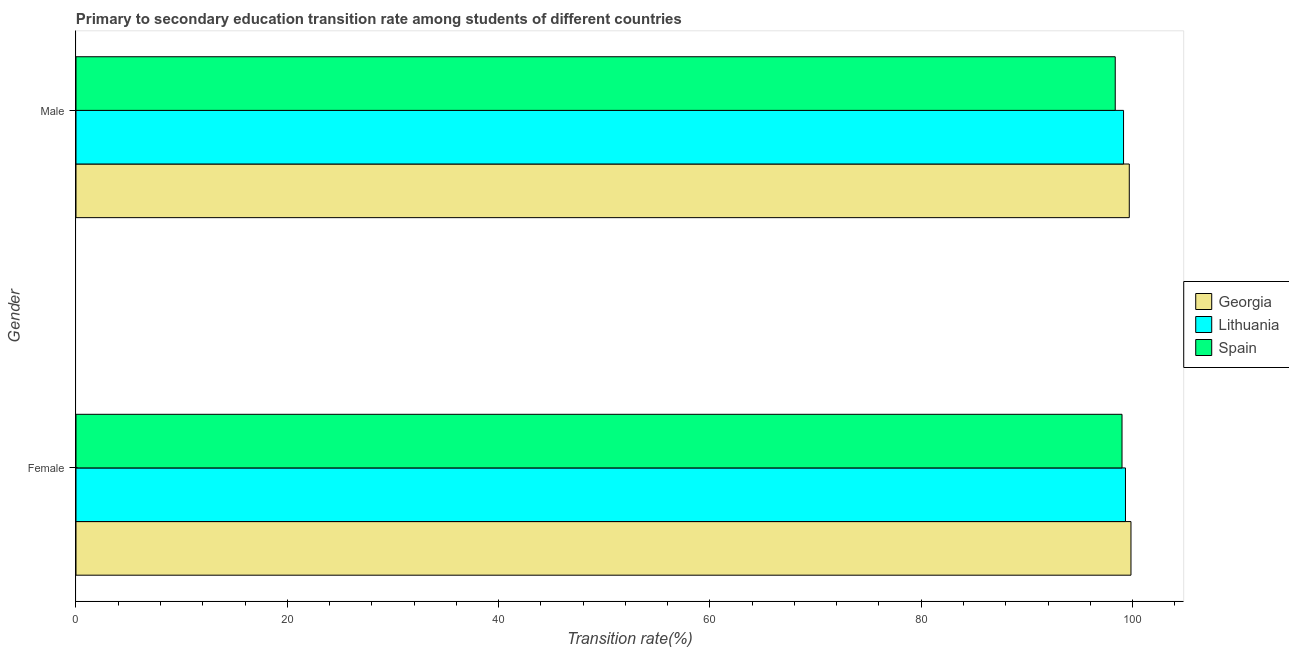How many different coloured bars are there?
Your answer should be compact. 3. How many groups of bars are there?
Ensure brevity in your answer.  2. Are the number of bars per tick equal to the number of legend labels?
Provide a succinct answer. Yes. How many bars are there on the 2nd tick from the bottom?
Your answer should be very brief. 3. What is the transition rate among male students in Spain?
Provide a succinct answer. 98.36. Across all countries, what is the maximum transition rate among male students?
Keep it short and to the point. 99.69. Across all countries, what is the minimum transition rate among male students?
Your answer should be very brief. 98.36. In which country was the transition rate among male students maximum?
Keep it short and to the point. Georgia. What is the total transition rate among male students in the graph?
Give a very brief answer. 297.21. What is the difference between the transition rate among male students in Lithuania and that in Spain?
Give a very brief answer. 0.79. What is the difference between the transition rate among female students in Georgia and the transition rate among male students in Lithuania?
Ensure brevity in your answer.  0.7. What is the average transition rate among male students per country?
Provide a succinct answer. 99.07. What is the difference between the transition rate among female students and transition rate among male students in Lithuania?
Provide a succinct answer. 0.18. In how many countries, is the transition rate among female students greater than 56 %?
Ensure brevity in your answer.  3. What is the ratio of the transition rate among female students in Lithuania to that in Georgia?
Ensure brevity in your answer.  0.99. Is the transition rate among male students in Spain less than that in Georgia?
Give a very brief answer. Yes. In how many countries, is the transition rate among female students greater than the average transition rate among female students taken over all countries?
Ensure brevity in your answer.  1. What does the 2nd bar from the top in Female represents?
Provide a short and direct response. Lithuania. What does the 2nd bar from the bottom in Female represents?
Your response must be concise. Lithuania. How many bars are there?
Give a very brief answer. 6. Are the values on the major ticks of X-axis written in scientific E-notation?
Keep it short and to the point. No. Does the graph contain grids?
Offer a very short reply. No. Where does the legend appear in the graph?
Your response must be concise. Center right. How are the legend labels stacked?
Your answer should be compact. Vertical. What is the title of the graph?
Your answer should be very brief. Primary to secondary education transition rate among students of different countries. Does "Myanmar" appear as one of the legend labels in the graph?
Give a very brief answer. No. What is the label or title of the X-axis?
Your answer should be very brief. Transition rate(%). What is the Transition rate(%) in Georgia in Female?
Give a very brief answer. 99.85. What is the Transition rate(%) in Lithuania in Female?
Offer a terse response. 99.33. What is the Transition rate(%) in Spain in Female?
Offer a very short reply. 99.01. What is the Transition rate(%) of Georgia in Male?
Your response must be concise. 99.69. What is the Transition rate(%) in Lithuania in Male?
Make the answer very short. 99.15. What is the Transition rate(%) in Spain in Male?
Offer a very short reply. 98.36. Across all Gender, what is the maximum Transition rate(%) of Georgia?
Offer a terse response. 99.85. Across all Gender, what is the maximum Transition rate(%) in Lithuania?
Provide a succinct answer. 99.33. Across all Gender, what is the maximum Transition rate(%) in Spain?
Ensure brevity in your answer.  99.01. Across all Gender, what is the minimum Transition rate(%) of Georgia?
Your response must be concise. 99.69. Across all Gender, what is the minimum Transition rate(%) of Lithuania?
Make the answer very short. 99.15. Across all Gender, what is the minimum Transition rate(%) of Spain?
Give a very brief answer. 98.36. What is the total Transition rate(%) of Georgia in the graph?
Ensure brevity in your answer.  199.55. What is the total Transition rate(%) of Lithuania in the graph?
Provide a succinct answer. 198.48. What is the total Transition rate(%) of Spain in the graph?
Keep it short and to the point. 197.37. What is the difference between the Transition rate(%) in Georgia in Female and that in Male?
Keep it short and to the point. 0.16. What is the difference between the Transition rate(%) of Lithuania in Female and that in Male?
Keep it short and to the point. 0.18. What is the difference between the Transition rate(%) in Spain in Female and that in Male?
Offer a very short reply. 0.64. What is the difference between the Transition rate(%) of Georgia in Female and the Transition rate(%) of Lithuania in Male?
Make the answer very short. 0.7. What is the difference between the Transition rate(%) in Georgia in Female and the Transition rate(%) in Spain in Male?
Your answer should be very brief. 1.49. What is the difference between the Transition rate(%) in Lithuania in Female and the Transition rate(%) in Spain in Male?
Provide a succinct answer. 0.97. What is the average Transition rate(%) of Georgia per Gender?
Your response must be concise. 99.77. What is the average Transition rate(%) in Lithuania per Gender?
Ensure brevity in your answer.  99.24. What is the average Transition rate(%) of Spain per Gender?
Offer a very short reply. 98.68. What is the difference between the Transition rate(%) in Georgia and Transition rate(%) in Lithuania in Female?
Give a very brief answer. 0.52. What is the difference between the Transition rate(%) in Georgia and Transition rate(%) in Spain in Female?
Offer a very short reply. 0.85. What is the difference between the Transition rate(%) in Lithuania and Transition rate(%) in Spain in Female?
Provide a succinct answer. 0.33. What is the difference between the Transition rate(%) of Georgia and Transition rate(%) of Lithuania in Male?
Your response must be concise. 0.54. What is the difference between the Transition rate(%) in Georgia and Transition rate(%) in Spain in Male?
Make the answer very short. 1.33. What is the difference between the Transition rate(%) in Lithuania and Transition rate(%) in Spain in Male?
Your answer should be compact. 0.79. What is the ratio of the Transition rate(%) of Georgia in Female to that in Male?
Provide a succinct answer. 1. What is the ratio of the Transition rate(%) in Lithuania in Female to that in Male?
Your answer should be compact. 1. What is the ratio of the Transition rate(%) in Spain in Female to that in Male?
Give a very brief answer. 1.01. What is the difference between the highest and the second highest Transition rate(%) in Georgia?
Make the answer very short. 0.16. What is the difference between the highest and the second highest Transition rate(%) in Lithuania?
Offer a terse response. 0.18. What is the difference between the highest and the second highest Transition rate(%) of Spain?
Offer a terse response. 0.64. What is the difference between the highest and the lowest Transition rate(%) of Georgia?
Ensure brevity in your answer.  0.16. What is the difference between the highest and the lowest Transition rate(%) in Lithuania?
Make the answer very short. 0.18. What is the difference between the highest and the lowest Transition rate(%) of Spain?
Provide a succinct answer. 0.64. 